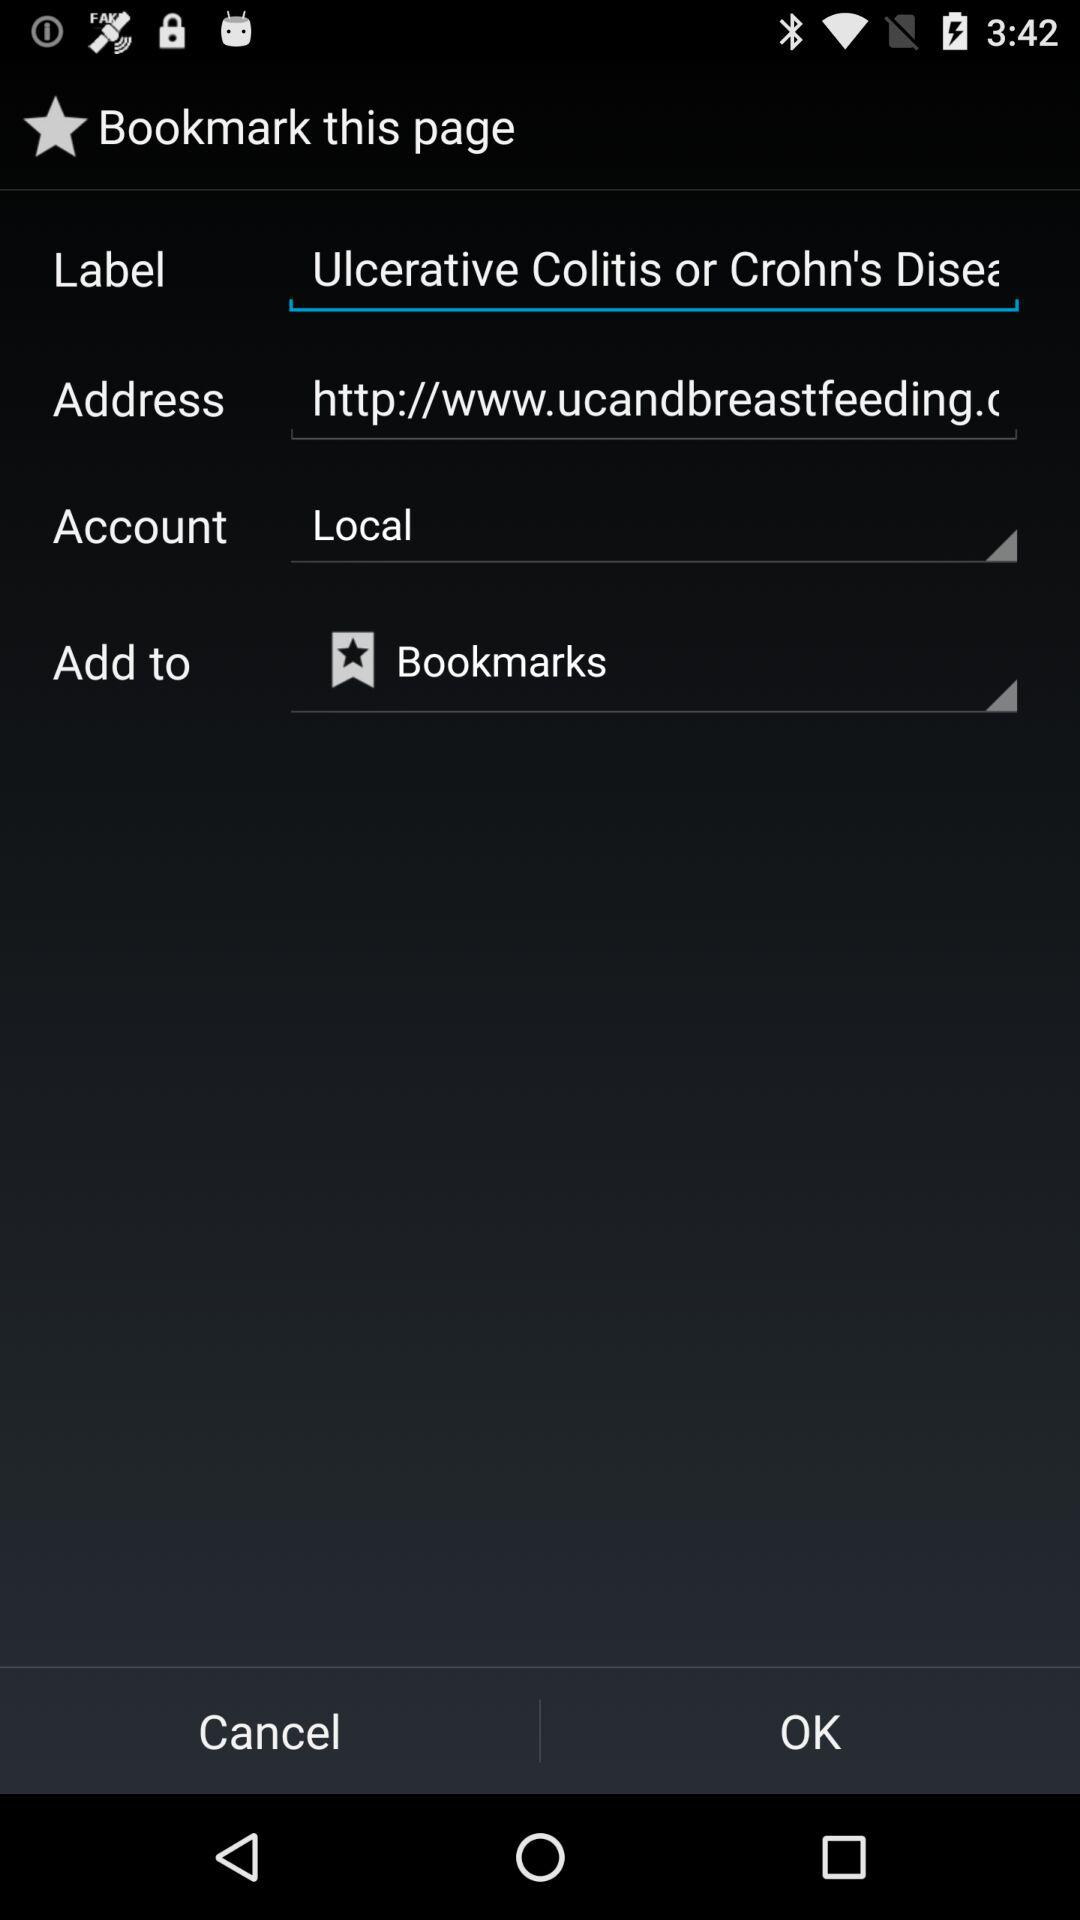Which option is selected in the account settings? The option that is selected in the account settings is "Local". 